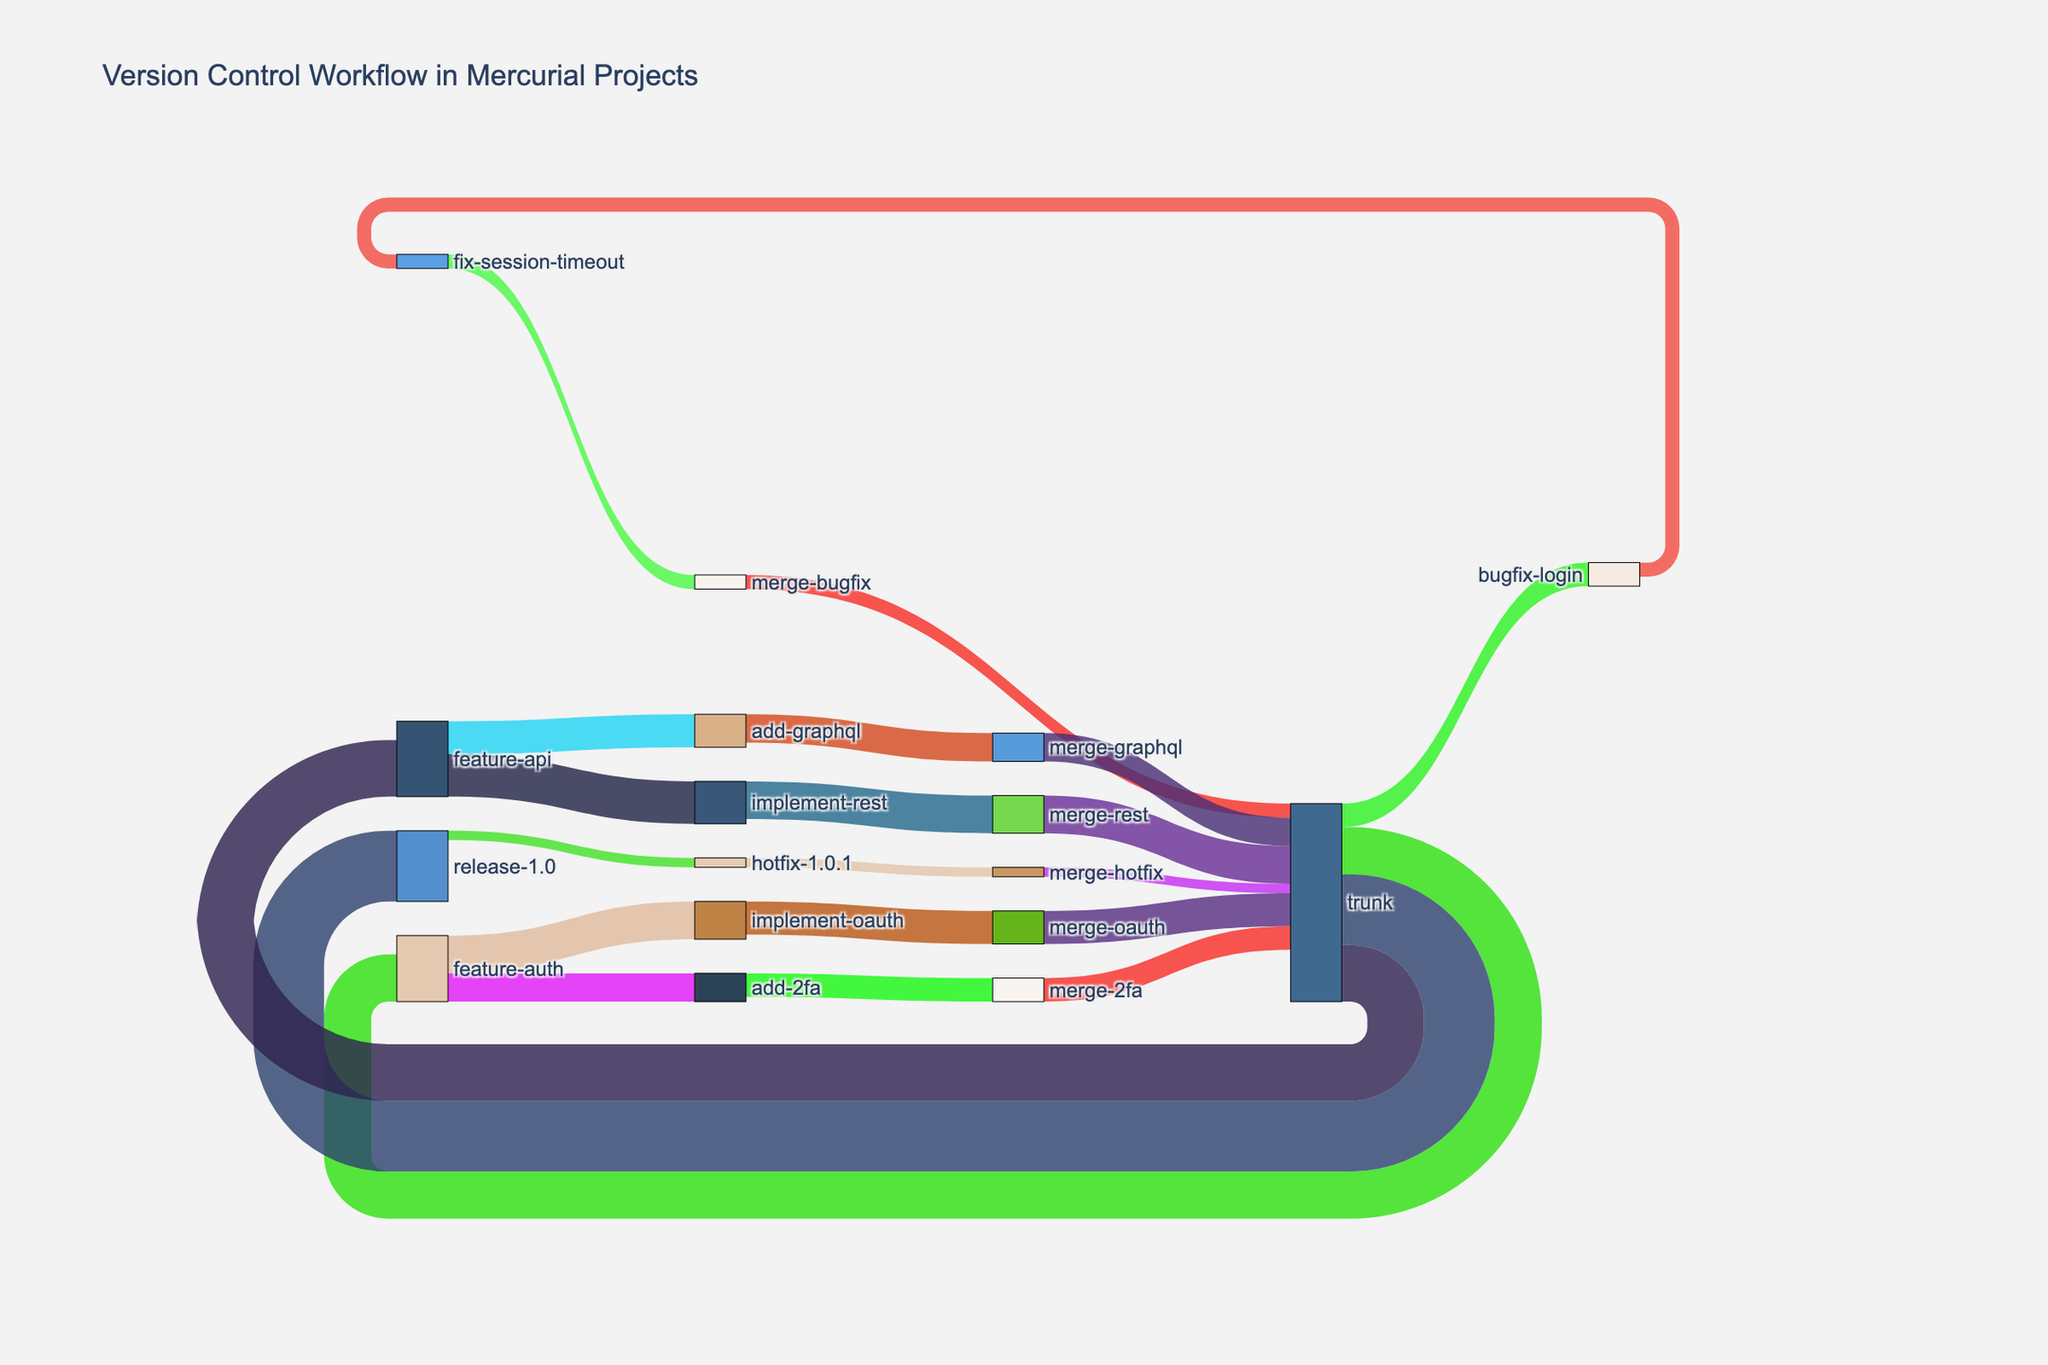Which branch has the highest number of commits? The branch "release-1.0" has the highest number of commits, which is 15, as shown in the figure.
Answer: release-1.0 How many commits are merged into the main trunk? Adding up all the merges into the main trunk: "merge-oauth" (7), "merge-2fa" (5), "merge-bugfix" (3), "merge-rest" (8), and "merge-graphql" (6), gives a total of 29 commits.
Answer: 29 What is the total number of commits in the "feature-api" branch and its sub-branches? Summing the commits in "feature-api" (12), "implement-rest" (9), and "add-graphql" (7) gives 28 commits.
Answer: 28 How many commits were made to fix issues in the "bugfix-login" branch and its sub-branches? Total commits in "bugfix-login" and "fix-session-timeout" are 5 (bugfix-login) + 3 (fix-session-timeout), resulting in 8 commits.
Answer: 8 Which feature branch has more commits, "feature-auth" or "feature-api"? "Feature-auth" has 10 + 8 + 6 = 24 commits, whereas "feature-api" has 12 + 9 + 7 = 28 commits. So, "feature-api" has more commits.
Answer: feature-api What is the combined number of commits in both "feature-auth" and "feature-api" branches and their sub-branches? The total commits in "feature-auth" and its sub-branches is 24, and for "feature-api" and its sub-branches is 28. Combined, it totals 24 + 28 = 52 commits.
Answer: 52 Which branch had the smallest number of commits before merging back into the main trunk? "Fix-session-timeout" branch had the smallest number of commits before merging, with just 3 commits.
Answer: fix-session-timeout 